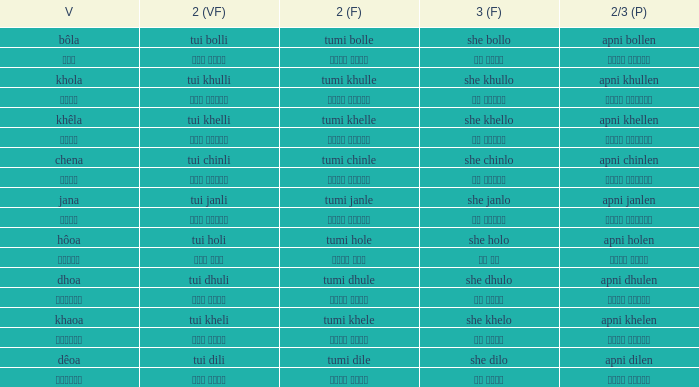What is the verb for Khola? She khullo. 